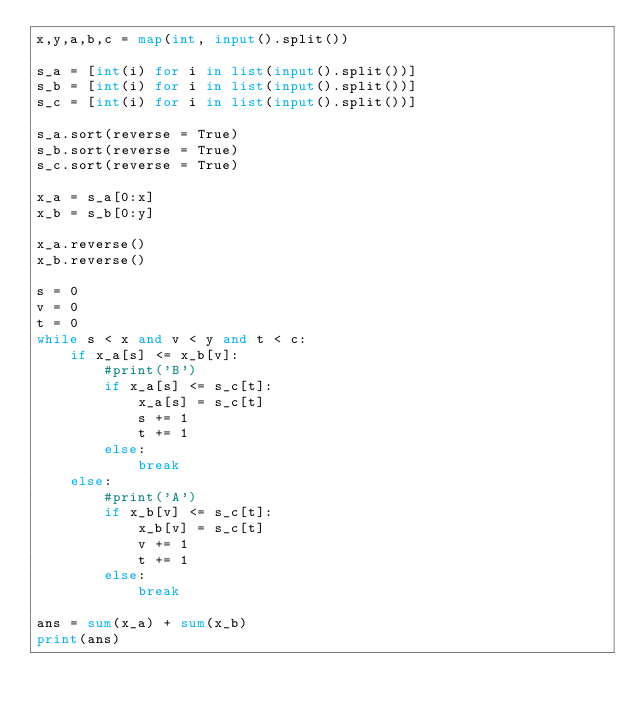<code> <loc_0><loc_0><loc_500><loc_500><_Python_>x,y,a,b,c = map(int, input().split())

s_a = [int(i) for i in list(input().split())]
s_b = [int(i) for i in list(input().split())]
s_c = [int(i) for i in list(input().split())]

s_a.sort(reverse = True)
s_b.sort(reverse = True)
s_c.sort(reverse = True)

x_a = s_a[0:x]
x_b = s_b[0:y]

x_a.reverse()
x_b.reverse()

s = 0
v = 0
t = 0
while s < x and v < y and t < c:
    if x_a[s] <= x_b[v]:
        #print('B')
        if x_a[s] <= s_c[t]:
            x_a[s] = s_c[t]
            s += 1
            t += 1
        else:
            break
    else:
        #print('A')
        if x_b[v] <= s_c[t]:
            x_b[v] = s_c[t]
            v += 1
            t += 1
        else:
            break

ans = sum(x_a) + sum(x_b)
print(ans)</code> 